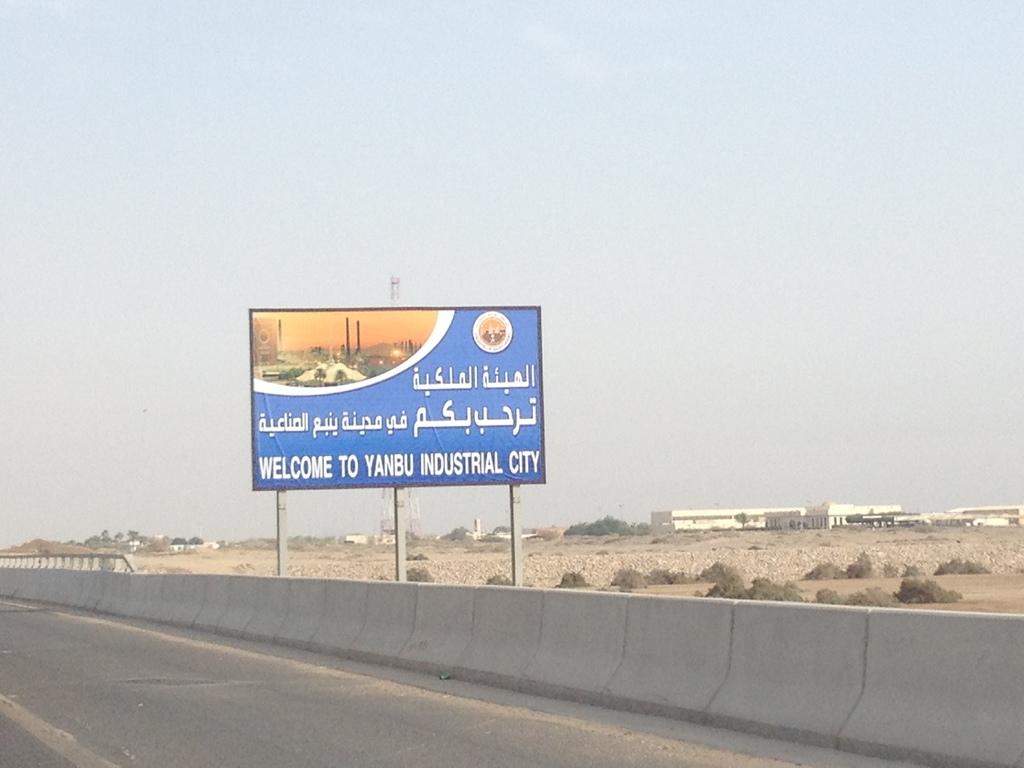What city is the welcome sign for?
Provide a succinct answer. Yanbu industrial city. What city are you coming in to?
Give a very brief answer. Yanbu industrial city. 